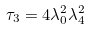Convert formula to latex. <formula><loc_0><loc_0><loc_500><loc_500>\tau _ { 3 } = 4 \lambda _ { 0 } ^ { 2 } \lambda _ { 4 } ^ { 2 }</formula> 